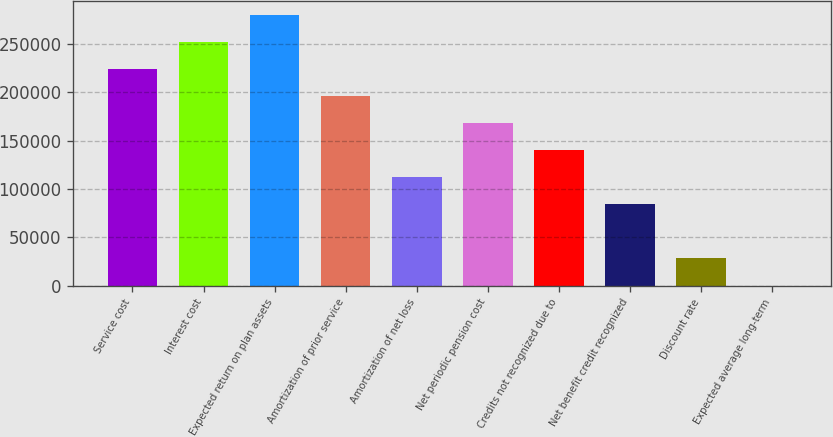Convert chart. <chart><loc_0><loc_0><loc_500><loc_500><bar_chart><fcel>Service cost<fcel>Interest cost<fcel>Expected return on plan assets<fcel>Amortization of prior service<fcel>Amortization of net loss<fcel>Net periodic pension cost<fcel>Credits not recognized due to<fcel>Net benefit credit recognized<fcel>Discount rate<fcel>Expected average long-term<nl><fcel>224052<fcel>252058<fcel>280064<fcel>196046<fcel>112028<fcel>168040<fcel>140034<fcel>84021.6<fcel>28009.5<fcel>3.5<nl></chart> 